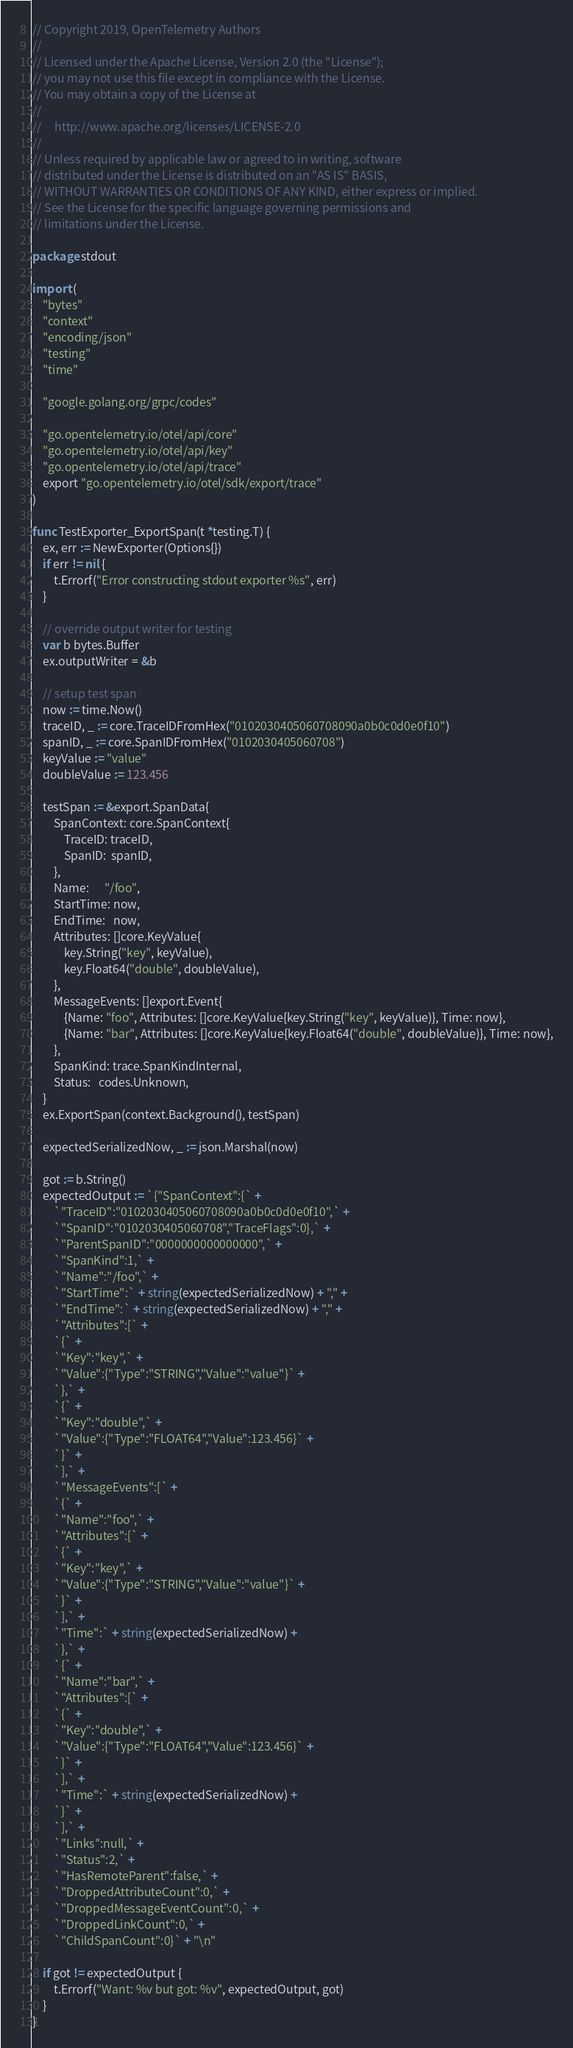<code> <loc_0><loc_0><loc_500><loc_500><_Go_>// Copyright 2019, OpenTelemetry Authors
//
// Licensed under the Apache License, Version 2.0 (the "License");
// you may not use this file except in compliance with the License.
// You may obtain a copy of the License at
//
//     http://www.apache.org/licenses/LICENSE-2.0
//
// Unless required by applicable law or agreed to in writing, software
// distributed under the License is distributed on an "AS IS" BASIS,
// WITHOUT WARRANTIES OR CONDITIONS OF ANY KIND, either express or implied.
// See the License for the specific language governing permissions and
// limitations under the License.

package stdout

import (
	"bytes"
	"context"
	"encoding/json"
	"testing"
	"time"

	"google.golang.org/grpc/codes"

	"go.opentelemetry.io/otel/api/core"
	"go.opentelemetry.io/otel/api/key"
	"go.opentelemetry.io/otel/api/trace"
	export "go.opentelemetry.io/otel/sdk/export/trace"
)

func TestExporter_ExportSpan(t *testing.T) {
	ex, err := NewExporter(Options{})
	if err != nil {
		t.Errorf("Error constructing stdout exporter %s", err)
	}

	// override output writer for testing
	var b bytes.Buffer
	ex.outputWriter = &b

	// setup test span
	now := time.Now()
	traceID, _ := core.TraceIDFromHex("0102030405060708090a0b0c0d0e0f10")
	spanID, _ := core.SpanIDFromHex("0102030405060708")
	keyValue := "value"
	doubleValue := 123.456

	testSpan := &export.SpanData{
		SpanContext: core.SpanContext{
			TraceID: traceID,
			SpanID:  spanID,
		},
		Name:      "/foo",
		StartTime: now,
		EndTime:   now,
		Attributes: []core.KeyValue{
			key.String("key", keyValue),
			key.Float64("double", doubleValue),
		},
		MessageEvents: []export.Event{
			{Name: "foo", Attributes: []core.KeyValue{key.String("key", keyValue)}, Time: now},
			{Name: "bar", Attributes: []core.KeyValue{key.Float64("double", doubleValue)}, Time: now},
		},
		SpanKind: trace.SpanKindInternal,
		Status:   codes.Unknown,
	}
	ex.ExportSpan(context.Background(), testSpan)

	expectedSerializedNow, _ := json.Marshal(now)

	got := b.String()
	expectedOutput := `{"SpanContext":{` +
		`"TraceID":"0102030405060708090a0b0c0d0e0f10",` +
		`"SpanID":"0102030405060708","TraceFlags":0},` +
		`"ParentSpanID":"0000000000000000",` +
		`"SpanKind":1,` +
		`"Name":"/foo",` +
		`"StartTime":` + string(expectedSerializedNow) + "," +
		`"EndTime":` + string(expectedSerializedNow) + "," +
		`"Attributes":[` +
		`{` +
		`"Key":"key",` +
		`"Value":{"Type":"STRING","Value":"value"}` +
		`},` +
		`{` +
		`"Key":"double",` +
		`"Value":{"Type":"FLOAT64","Value":123.456}` +
		`}` +
		`],` +
		`"MessageEvents":[` +
		`{` +
		`"Name":"foo",` +
		`"Attributes":[` +
		`{` +
		`"Key":"key",` +
		`"Value":{"Type":"STRING","Value":"value"}` +
		`}` +
		`],` +
		`"Time":` + string(expectedSerializedNow) +
		`},` +
		`{` +
		`"Name":"bar",` +
		`"Attributes":[` +
		`{` +
		`"Key":"double",` +
		`"Value":{"Type":"FLOAT64","Value":123.456}` +
		`}` +
		`],` +
		`"Time":` + string(expectedSerializedNow) +
		`}` +
		`],` +
		`"Links":null,` +
		`"Status":2,` +
		`"HasRemoteParent":false,` +
		`"DroppedAttributeCount":0,` +
		`"DroppedMessageEventCount":0,` +
		`"DroppedLinkCount":0,` +
		`"ChildSpanCount":0}` + "\n"

	if got != expectedOutput {
		t.Errorf("Want: %v but got: %v", expectedOutput, got)
	}
}
</code> 